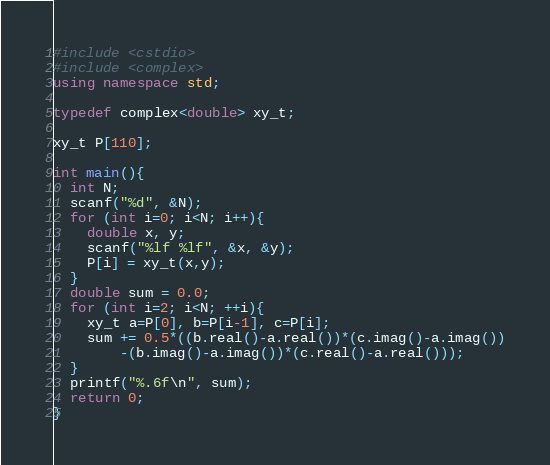Convert code to text. <code><loc_0><loc_0><loc_500><loc_500><_C++_>#include <cstdio>
#include <complex>
using namespace std;

typedef complex<double> xy_t;

xy_t P[110];

int main(){
  int N;
  scanf("%d", &N);
  for (int i=0; i<N; i++){
    double x, y;
    scanf("%lf %lf", &x, &y);
    P[i] = xy_t(x,y);
  }
  double sum = 0.0;
  for (int i=2; i<N; ++i){
    xy_t a=P[0], b=P[i-1], c=P[i];
    sum += 0.5*((b.real()-a.real())*(c.imag()-a.imag())
		-(b.imag()-a.imag())*(c.real()-a.real()));
  }
  printf("%.6f\n", sum);
  return 0;
}</code> 